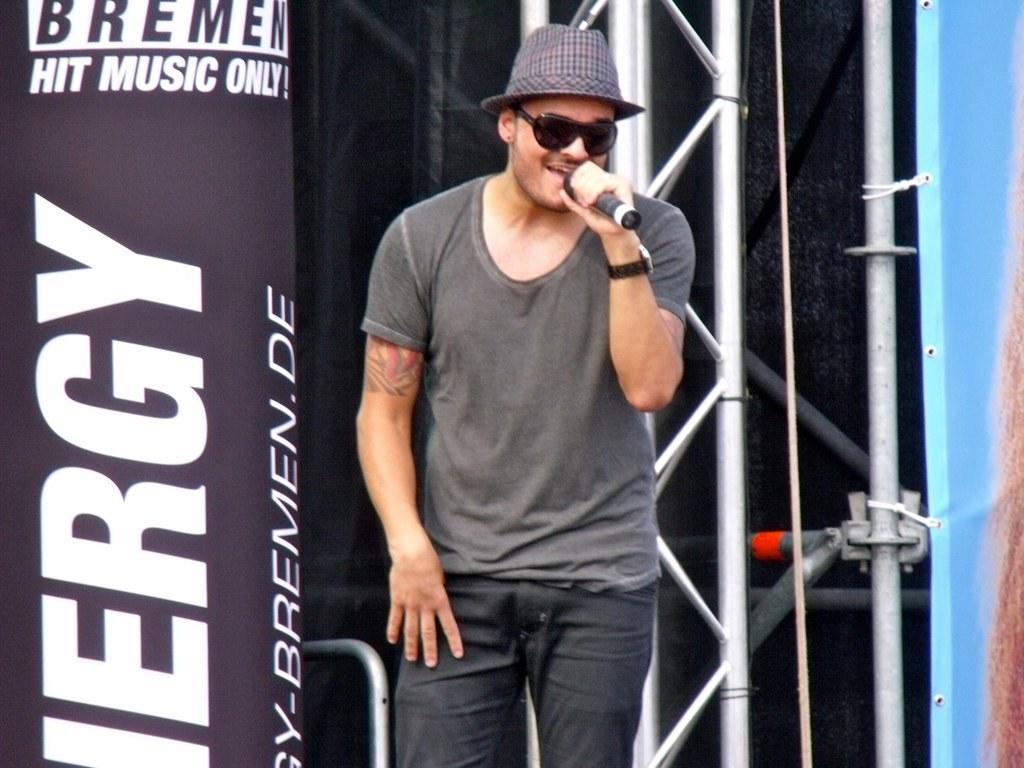What is the main subject of the image? The main subject of the image is a man. What is the man wearing? The man is wearing a black shirt and black pants. What is the man holding in his hand? The man is holding a mic in his hand. What color is the background of the image? The background of the image is black cotton. What else can be seen in the image that is black in color? There is a black color poster in the image. What type of government is depicted on the bag in the image? There is no bag present in the image, so it is not possible to determine the type of government depicted on it. 